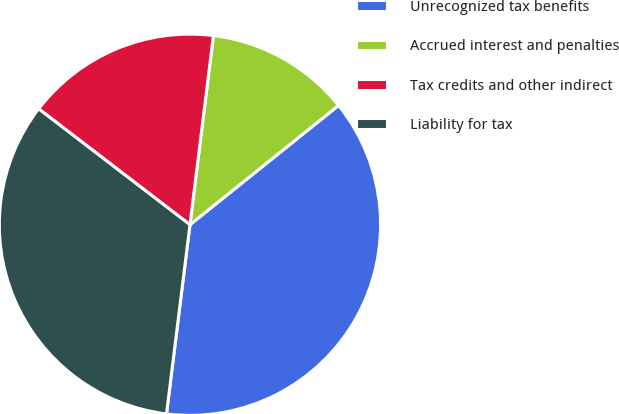Convert chart to OTSL. <chart><loc_0><loc_0><loc_500><loc_500><pie_chart><fcel>Unrecognized tax benefits<fcel>Accrued interest and penalties<fcel>Tax credits and other indirect<fcel>Liability for tax<nl><fcel>37.73%<fcel>12.27%<fcel>16.56%<fcel>33.44%<nl></chart> 